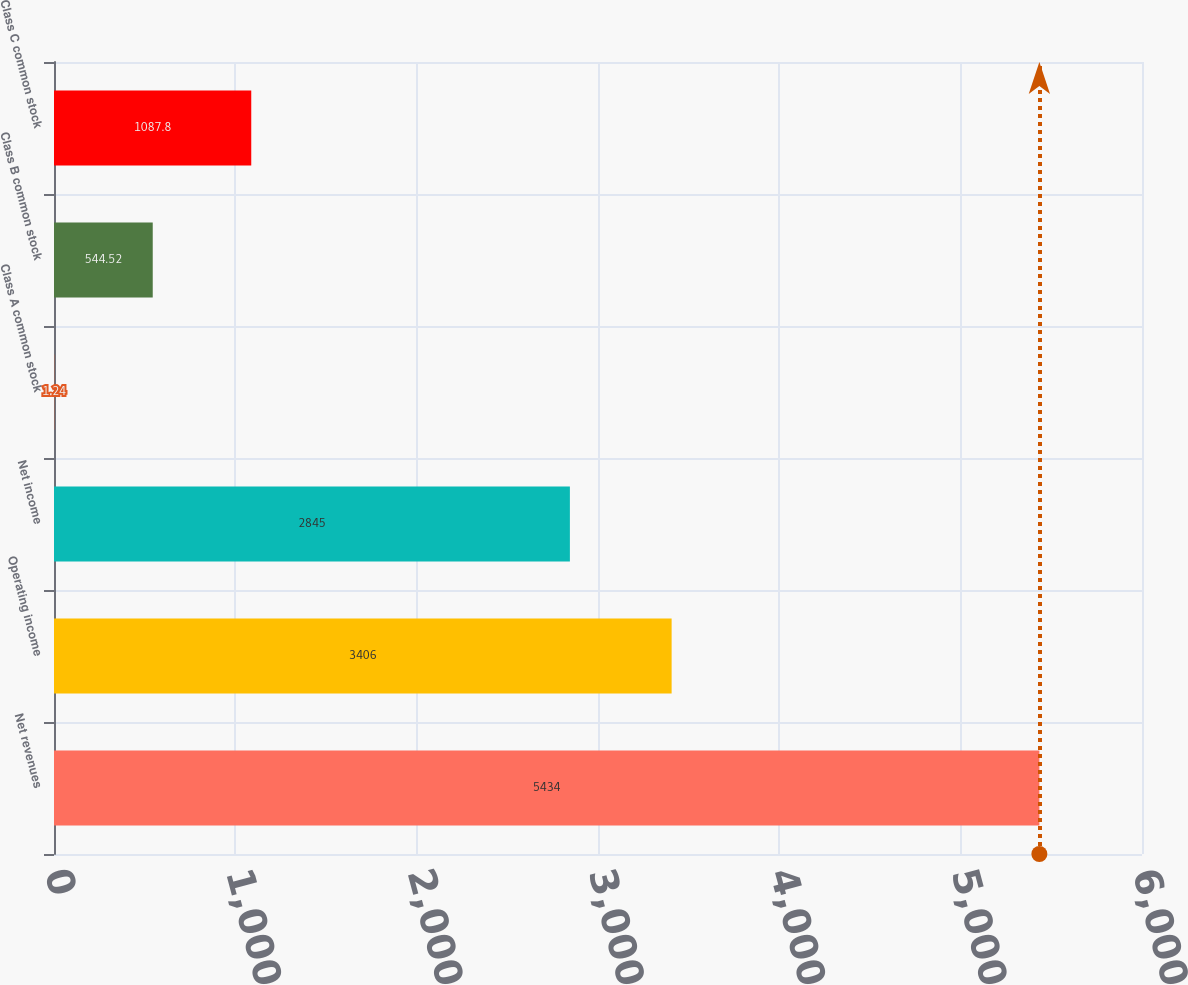<chart> <loc_0><loc_0><loc_500><loc_500><bar_chart><fcel>Net revenues<fcel>Operating income<fcel>Net income<fcel>Class A common stock<fcel>Class B common stock<fcel>Class C common stock<nl><fcel>5434<fcel>3406<fcel>2845<fcel>1.24<fcel>544.52<fcel>1087.8<nl></chart> 